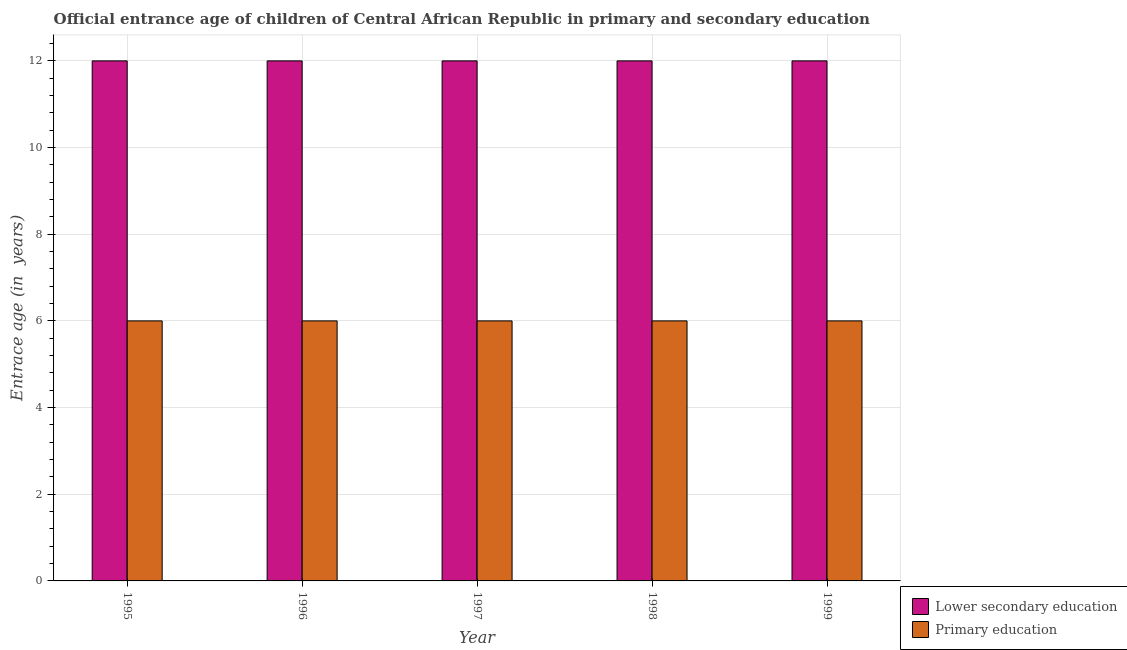How many different coloured bars are there?
Your answer should be compact. 2. Are the number of bars per tick equal to the number of legend labels?
Offer a very short reply. Yes. How many bars are there on the 3rd tick from the right?
Ensure brevity in your answer.  2. In how many cases, is the number of bars for a given year not equal to the number of legend labels?
Give a very brief answer. 0. What is the entrance age of children in lower secondary education in 1998?
Ensure brevity in your answer.  12. Across all years, what is the maximum entrance age of chiildren in primary education?
Keep it short and to the point. 6. In which year was the entrance age of chiildren in primary education maximum?
Offer a very short reply. 1995. What is the total entrance age of children in lower secondary education in the graph?
Keep it short and to the point. 60. What is the difference between the entrance age of chiildren in primary education in 1996 and that in 1998?
Make the answer very short. 0. What is the average entrance age of children in lower secondary education per year?
Your answer should be compact. 12. In the year 1995, what is the difference between the entrance age of children in lower secondary education and entrance age of chiildren in primary education?
Offer a very short reply. 0. What is the ratio of the entrance age of children in lower secondary education in 1995 to that in 1997?
Your response must be concise. 1. Is the difference between the entrance age of chiildren in primary education in 1998 and 1999 greater than the difference between the entrance age of children in lower secondary education in 1998 and 1999?
Keep it short and to the point. No. In how many years, is the entrance age of chiildren in primary education greater than the average entrance age of chiildren in primary education taken over all years?
Your answer should be compact. 0. What does the 1st bar from the left in 1997 represents?
Ensure brevity in your answer.  Lower secondary education. What does the 1st bar from the right in 1998 represents?
Keep it short and to the point. Primary education. Are all the bars in the graph horizontal?
Give a very brief answer. No. How many years are there in the graph?
Ensure brevity in your answer.  5. What is the difference between two consecutive major ticks on the Y-axis?
Offer a very short reply. 2. Does the graph contain any zero values?
Provide a short and direct response. No. Does the graph contain grids?
Ensure brevity in your answer.  Yes. Where does the legend appear in the graph?
Your response must be concise. Bottom right. How many legend labels are there?
Your answer should be very brief. 2. How are the legend labels stacked?
Offer a terse response. Vertical. What is the title of the graph?
Your response must be concise. Official entrance age of children of Central African Republic in primary and secondary education. Does "Urban Population" appear as one of the legend labels in the graph?
Your answer should be compact. No. What is the label or title of the Y-axis?
Offer a terse response. Entrace age (in  years). What is the Entrace age (in  years) of Primary education in 1995?
Your response must be concise. 6. What is the Entrace age (in  years) of Lower secondary education in 1996?
Your answer should be very brief. 12. What is the Entrace age (in  years) of Primary education in 1998?
Provide a succinct answer. 6. What is the Entrace age (in  years) of Lower secondary education in 1999?
Provide a short and direct response. 12. Across all years, what is the maximum Entrace age (in  years) in Primary education?
Offer a very short reply. 6. Across all years, what is the minimum Entrace age (in  years) of Lower secondary education?
Offer a very short reply. 12. Across all years, what is the minimum Entrace age (in  years) in Primary education?
Ensure brevity in your answer.  6. What is the total Entrace age (in  years) in Lower secondary education in the graph?
Give a very brief answer. 60. What is the total Entrace age (in  years) in Primary education in the graph?
Ensure brevity in your answer.  30. What is the difference between the Entrace age (in  years) in Primary education in 1995 and that in 1996?
Your response must be concise. 0. What is the difference between the Entrace age (in  years) in Lower secondary education in 1995 and that in 1997?
Keep it short and to the point. 0. What is the difference between the Entrace age (in  years) in Primary education in 1995 and that in 1998?
Give a very brief answer. 0. What is the difference between the Entrace age (in  years) of Lower secondary education in 1996 and that in 1997?
Make the answer very short. 0. What is the difference between the Entrace age (in  years) of Lower secondary education in 1996 and that in 1998?
Give a very brief answer. 0. What is the difference between the Entrace age (in  years) in Primary education in 1996 and that in 1998?
Make the answer very short. 0. What is the difference between the Entrace age (in  years) in Primary education in 1996 and that in 1999?
Provide a succinct answer. 0. What is the difference between the Entrace age (in  years) in Lower secondary education in 1997 and that in 1999?
Keep it short and to the point. 0. What is the difference between the Entrace age (in  years) in Primary education in 1997 and that in 1999?
Provide a succinct answer. 0. What is the difference between the Entrace age (in  years) in Lower secondary education in 1998 and that in 1999?
Offer a very short reply. 0. What is the difference between the Entrace age (in  years) in Primary education in 1998 and that in 1999?
Give a very brief answer. 0. What is the difference between the Entrace age (in  years) in Lower secondary education in 1995 and the Entrace age (in  years) in Primary education in 1996?
Your answer should be very brief. 6. What is the difference between the Entrace age (in  years) of Lower secondary education in 1995 and the Entrace age (in  years) of Primary education in 1997?
Your answer should be compact. 6. What is the difference between the Entrace age (in  years) of Lower secondary education in 1995 and the Entrace age (in  years) of Primary education in 1998?
Your response must be concise. 6. What is the difference between the Entrace age (in  years) in Lower secondary education in 1996 and the Entrace age (in  years) in Primary education in 1998?
Keep it short and to the point. 6. What is the average Entrace age (in  years) of Lower secondary education per year?
Give a very brief answer. 12. What is the average Entrace age (in  years) in Primary education per year?
Offer a terse response. 6. In the year 1995, what is the difference between the Entrace age (in  years) of Lower secondary education and Entrace age (in  years) of Primary education?
Give a very brief answer. 6. In the year 1998, what is the difference between the Entrace age (in  years) of Lower secondary education and Entrace age (in  years) of Primary education?
Ensure brevity in your answer.  6. What is the ratio of the Entrace age (in  years) of Primary education in 1995 to that in 1999?
Your answer should be compact. 1. What is the ratio of the Entrace age (in  years) in Lower secondary education in 1998 to that in 1999?
Your answer should be very brief. 1. What is the ratio of the Entrace age (in  years) of Primary education in 1998 to that in 1999?
Offer a terse response. 1. What is the difference between the highest and the lowest Entrace age (in  years) in Lower secondary education?
Ensure brevity in your answer.  0. 